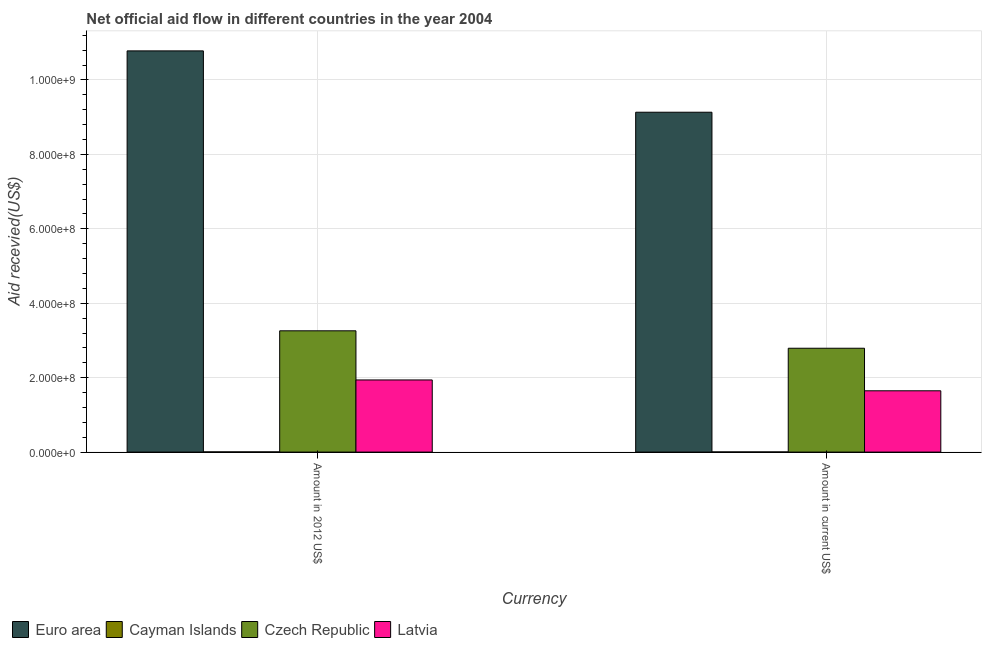How many different coloured bars are there?
Keep it short and to the point. 4. How many bars are there on the 1st tick from the left?
Keep it short and to the point. 4. How many bars are there on the 1st tick from the right?
Offer a terse response. 4. What is the label of the 2nd group of bars from the left?
Offer a terse response. Amount in current US$. What is the amount of aid received(expressed in 2012 us$) in Euro area?
Offer a very short reply. 1.08e+09. Across all countries, what is the maximum amount of aid received(expressed in 2012 us$)?
Ensure brevity in your answer.  1.08e+09. Across all countries, what is the minimum amount of aid received(expressed in us$)?
Ensure brevity in your answer.  3.90e+05. In which country was the amount of aid received(expressed in us$) maximum?
Ensure brevity in your answer.  Euro area. In which country was the amount of aid received(expressed in us$) minimum?
Your answer should be compact. Cayman Islands. What is the total amount of aid received(expressed in us$) in the graph?
Offer a terse response. 1.36e+09. What is the difference between the amount of aid received(expressed in us$) in Cayman Islands and that in Euro area?
Offer a very short reply. -9.13e+08. What is the difference between the amount of aid received(expressed in us$) in Czech Republic and the amount of aid received(expressed in 2012 us$) in Cayman Islands?
Your answer should be compact. 2.79e+08. What is the average amount of aid received(expressed in 2012 us$) per country?
Offer a very short reply. 4.00e+08. What is the difference between the amount of aid received(expressed in us$) and amount of aid received(expressed in 2012 us$) in Latvia?
Offer a terse response. -2.91e+07. What is the ratio of the amount of aid received(expressed in 2012 us$) in Latvia to that in Cayman Islands?
Keep it short and to the point. 395.59. Is the amount of aid received(expressed in 2012 us$) in Latvia less than that in Euro area?
Your answer should be very brief. Yes. In how many countries, is the amount of aid received(expressed in 2012 us$) greater than the average amount of aid received(expressed in 2012 us$) taken over all countries?
Ensure brevity in your answer.  1. What does the 2nd bar from the left in Amount in 2012 US$ represents?
Offer a terse response. Cayman Islands. How many bars are there?
Provide a short and direct response. 8. How many countries are there in the graph?
Make the answer very short. 4. What is the difference between two consecutive major ticks on the Y-axis?
Keep it short and to the point. 2.00e+08. Are the values on the major ticks of Y-axis written in scientific E-notation?
Provide a short and direct response. Yes. Does the graph contain any zero values?
Your response must be concise. No. Where does the legend appear in the graph?
Offer a very short reply. Bottom left. How many legend labels are there?
Give a very brief answer. 4. How are the legend labels stacked?
Your response must be concise. Horizontal. What is the title of the graph?
Offer a terse response. Net official aid flow in different countries in the year 2004. What is the label or title of the X-axis?
Give a very brief answer. Currency. What is the label or title of the Y-axis?
Make the answer very short. Aid recevied(US$). What is the Aid recevied(US$) in Euro area in Amount in 2012 US$?
Your answer should be very brief. 1.08e+09. What is the Aid recevied(US$) in Cayman Islands in Amount in 2012 US$?
Offer a very short reply. 4.90e+05. What is the Aid recevied(US$) in Czech Republic in Amount in 2012 US$?
Offer a very short reply. 3.26e+08. What is the Aid recevied(US$) in Latvia in Amount in 2012 US$?
Provide a succinct answer. 1.94e+08. What is the Aid recevied(US$) of Euro area in Amount in current US$?
Make the answer very short. 9.13e+08. What is the Aid recevied(US$) of Czech Republic in Amount in current US$?
Ensure brevity in your answer.  2.79e+08. What is the Aid recevied(US$) of Latvia in Amount in current US$?
Offer a terse response. 1.65e+08. Across all Currency, what is the maximum Aid recevied(US$) in Euro area?
Your answer should be very brief. 1.08e+09. Across all Currency, what is the maximum Aid recevied(US$) of Czech Republic?
Your answer should be very brief. 3.26e+08. Across all Currency, what is the maximum Aid recevied(US$) in Latvia?
Provide a succinct answer. 1.94e+08. Across all Currency, what is the minimum Aid recevied(US$) in Euro area?
Your answer should be compact. 9.13e+08. Across all Currency, what is the minimum Aid recevied(US$) of Czech Republic?
Your response must be concise. 2.79e+08. Across all Currency, what is the minimum Aid recevied(US$) of Latvia?
Your answer should be compact. 1.65e+08. What is the total Aid recevied(US$) of Euro area in the graph?
Offer a terse response. 1.99e+09. What is the total Aid recevied(US$) of Cayman Islands in the graph?
Your answer should be very brief. 8.80e+05. What is the total Aid recevied(US$) in Czech Republic in the graph?
Offer a very short reply. 6.05e+08. What is the total Aid recevied(US$) in Latvia in the graph?
Your answer should be compact. 3.59e+08. What is the difference between the Aid recevied(US$) in Euro area in Amount in 2012 US$ and that in Amount in current US$?
Keep it short and to the point. 1.65e+08. What is the difference between the Aid recevied(US$) in Czech Republic in Amount in 2012 US$ and that in Amount in current US$?
Offer a very short reply. 4.68e+07. What is the difference between the Aid recevied(US$) of Latvia in Amount in 2012 US$ and that in Amount in current US$?
Provide a succinct answer. 2.91e+07. What is the difference between the Aid recevied(US$) in Euro area in Amount in 2012 US$ and the Aid recevied(US$) in Cayman Islands in Amount in current US$?
Your response must be concise. 1.08e+09. What is the difference between the Aid recevied(US$) of Euro area in Amount in 2012 US$ and the Aid recevied(US$) of Czech Republic in Amount in current US$?
Your response must be concise. 7.99e+08. What is the difference between the Aid recevied(US$) of Euro area in Amount in 2012 US$ and the Aid recevied(US$) of Latvia in Amount in current US$?
Give a very brief answer. 9.13e+08. What is the difference between the Aid recevied(US$) of Cayman Islands in Amount in 2012 US$ and the Aid recevied(US$) of Czech Republic in Amount in current US$?
Your answer should be very brief. -2.79e+08. What is the difference between the Aid recevied(US$) in Cayman Islands in Amount in 2012 US$ and the Aid recevied(US$) in Latvia in Amount in current US$?
Your response must be concise. -1.64e+08. What is the difference between the Aid recevied(US$) in Czech Republic in Amount in 2012 US$ and the Aid recevied(US$) in Latvia in Amount in current US$?
Give a very brief answer. 1.61e+08. What is the average Aid recevied(US$) in Euro area per Currency?
Keep it short and to the point. 9.96e+08. What is the average Aid recevied(US$) in Czech Republic per Currency?
Ensure brevity in your answer.  3.02e+08. What is the average Aid recevied(US$) in Latvia per Currency?
Give a very brief answer. 1.79e+08. What is the difference between the Aid recevied(US$) in Euro area and Aid recevied(US$) in Cayman Islands in Amount in 2012 US$?
Keep it short and to the point. 1.08e+09. What is the difference between the Aid recevied(US$) of Euro area and Aid recevied(US$) of Czech Republic in Amount in 2012 US$?
Offer a terse response. 7.52e+08. What is the difference between the Aid recevied(US$) in Euro area and Aid recevied(US$) in Latvia in Amount in 2012 US$?
Offer a terse response. 8.84e+08. What is the difference between the Aid recevied(US$) in Cayman Islands and Aid recevied(US$) in Czech Republic in Amount in 2012 US$?
Provide a succinct answer. -3.25e+08. What is the difference between the Aid recevied(US$) in Cayman Islands and Aid recevied(US$) in Latvia in Amount in 2012 US$?
Offer a very short reply. -1.93e+08. What is the difference between the Aid recevied(US$) in Czech Republic and Aid recevied(US$) in Latvia in Amount in 2012 US$?
Provide a short and direct response. 1.32e+08. What is the difference between the Aid recevied(US$) of Euro area and Aid recevied(US$) of Cayman Islands in Amount in current US$?
Make the answer very short. 9.13e+08. What is the difference between the Aid recevied(US$) in Euro area and Aid recevied(US$) in Czech Republic in Amount in current US$?
Give a very brief answer. 6.34e+08. What is the difference between the Aid recevied(US$) of Euro area and Aid recevied(US$) of Latvia in Amount in current US$?
Provide a succinct answer. 7.49e+08. What is the difference between the Aid recevied(US$) in Cayman Islands and Aid recevied(US$) in Czech Republic in Amount in current US$?
Make the answer very short. -2.79e+08. What is the difference between the Aid recevied(US$) of Cayman Islands and Aid recevied(US$) of Latvia in Amount in current US$?
Offer a terse response. -1.64e+08. What is the difference between the Aid recevied(US$) in Czech Republic and Aid recevied(US$) in Latvia in Amount in current US$?
Provide a succinct answer. 1.14e+08. What is the ratio of the Aid recevied(US$) of Euro area in Amount in 2012 US$ to that in Amount in current US$?
Your answer should be compact. 1.18. What is the ratio of the Aid recevied(US$) in Cayman Islands in Amount in 2012 US$ to that in Amount in current US$?
Make the answer very short. 1.26. What is the ratio of the Aid recevied(US$) of Czech Republic in Amount in 2012 US$ to that in Amount in current US$?
Your answer should be compact. 1.17. What is the ratio of the Aid recevied(US$) in Latvia in Amount in 2012 US$ to that in Amount in current US$?
Your response must be concise. 1.18. What is the difference between the highest and the second highest Aid recevied(US$) of Euro area?
Ensure brevity in your answer.  1.65e+08. What is the difference between the highest and the second highest Aid recevied(US$) in Czech Republic?
Ensure brevity in your answer.  4.68e+07. What is the difference between the highest and the second highest Aid recevied(US$) of Latvia?
Keep it short and to the point. 2.91e+07. What is the difference between the highest and the lowest Aid recevied(US$) of Euro area?
Provide a succinct answer. 1.65e+08. What is the difference between the highest and the lowest Aid recevied(US$) in Czech Republic?
Keep it short and to the point. 4.68e+07. What is the difference between the highest and the lowest Aid recevied(US$) of Latvia?
Provide a succinct answer. 2.91e+07. 